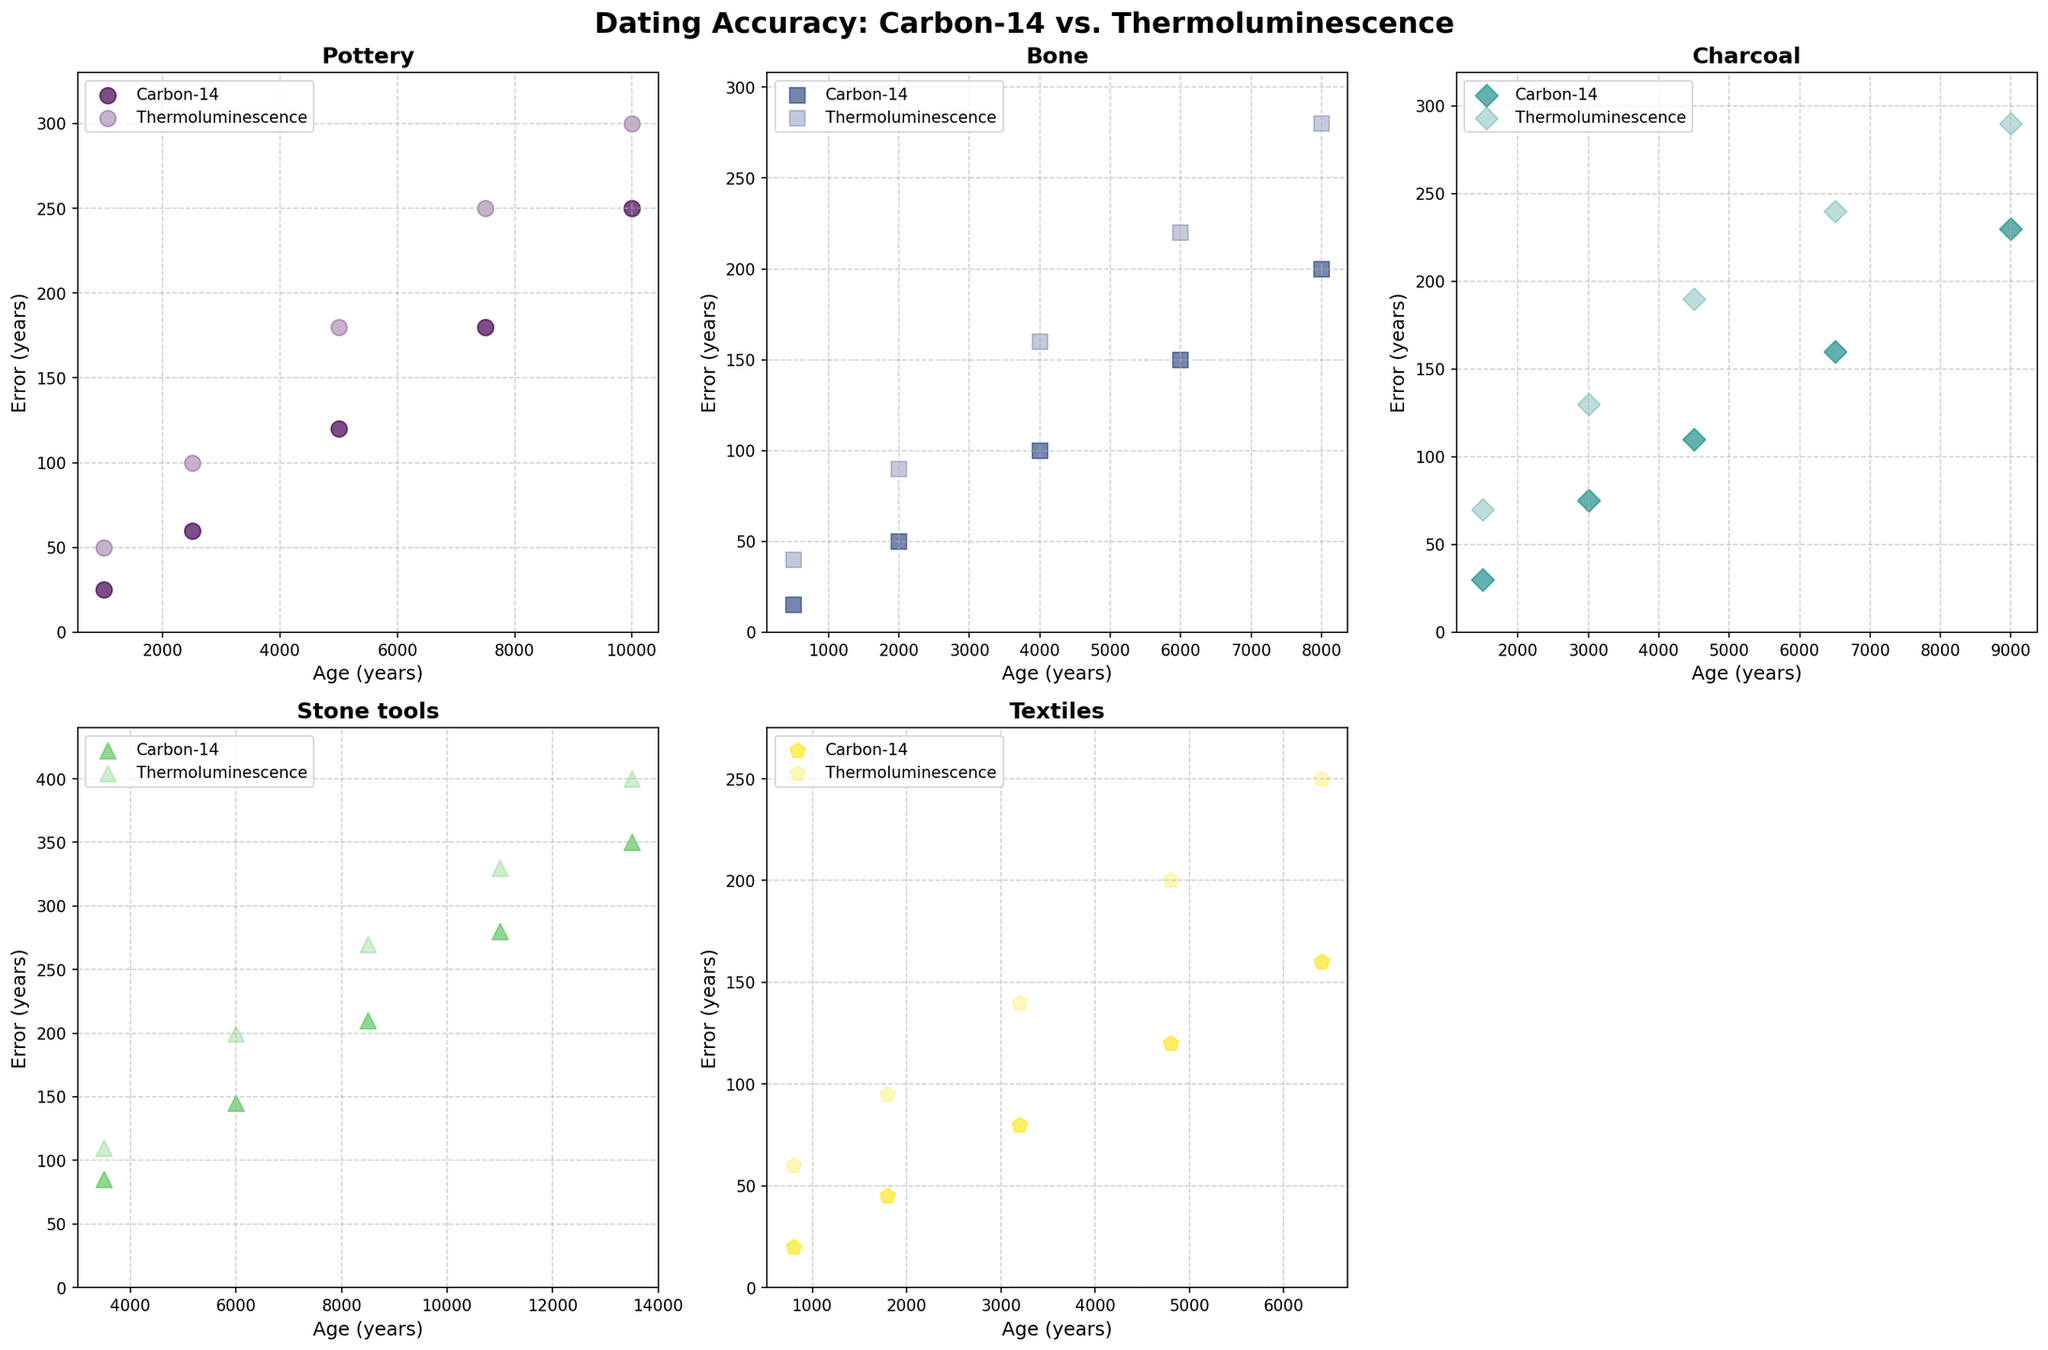What's the artifact type with the highest error in Thermoluminescence for the oldest item? Look at the subplots and find the scatter point with the oldest age. Among these points, the highest error in Thermoluminescence is on "Stone tools".
Answer: Stone tools Which method generally shows higher error margins for ancient artifacts, Carbon-14 or Thermoluminescence? Check the scatter points for older artifacts in all subplots. Thermoluminescence errors (less opaque points) are generally higher than Carbon-14 errors (more opaque points).
Answer: Thermoluminescence For Pottery, what is the age range where Carbon-14 errors are the smallest in relation to Thermoluminescence errors? Look at the subplot for Pottery and compare the error points for different ages. The smallest difference between Carbon-14 and Thermoluminescence errors occurs at 1000 years.
Answer: 1000 years Which artifact type has the smallest Carbon-14 error margin for items aged around 1500 years? Refer to the subplots and look at the scatter points around 1500 years. For 1500 years, the smallest Carbon-14 error margin is in "Textiles".
Answer: Textiles What is the average Thermoluminescence error for Bone artifacts aged 2000 and 6000 years? Check the subplot for Bone and find Thermoluminescence errors for 2000 and 6000 years (90 and 220). Average them: (90 + 220) / 2 = 155.
Answer: 155 Which artifact shows similar error margins for Carbon-14 and Thermoluminescence at an approximate age of 4500 years? Check the subplots for items around 4500 years. "Charcoal" has close errors (110 for Carbon-14, 190 for Thermoluminescence).
Answer: Charcoal For Textiles, how much does the Carbon-14 error increase from 800 to 3200 years? Locate the Carbon-14 points for 800 and 3200 years (20 and 80). The increase is 80 - 20 = 60 years.
Answer: 60 years At what age does the Thermoluminescence error for Stone tools first exceed 300 years? Check the Stone tools subplot for the age where Thermoluminescence (less opaque) errors cross 300. It happens first at 11000 years.
Answer: 11000 years Comparing Bone and Pottery artifacts of similar age, which has a more consistent Carbon-14 error margin? Compare Bone and Pottery subplots for their Carbon-14 error points. Bone errors are generally closer together than Pottery, indicating more consistency.
Answer: Bone 